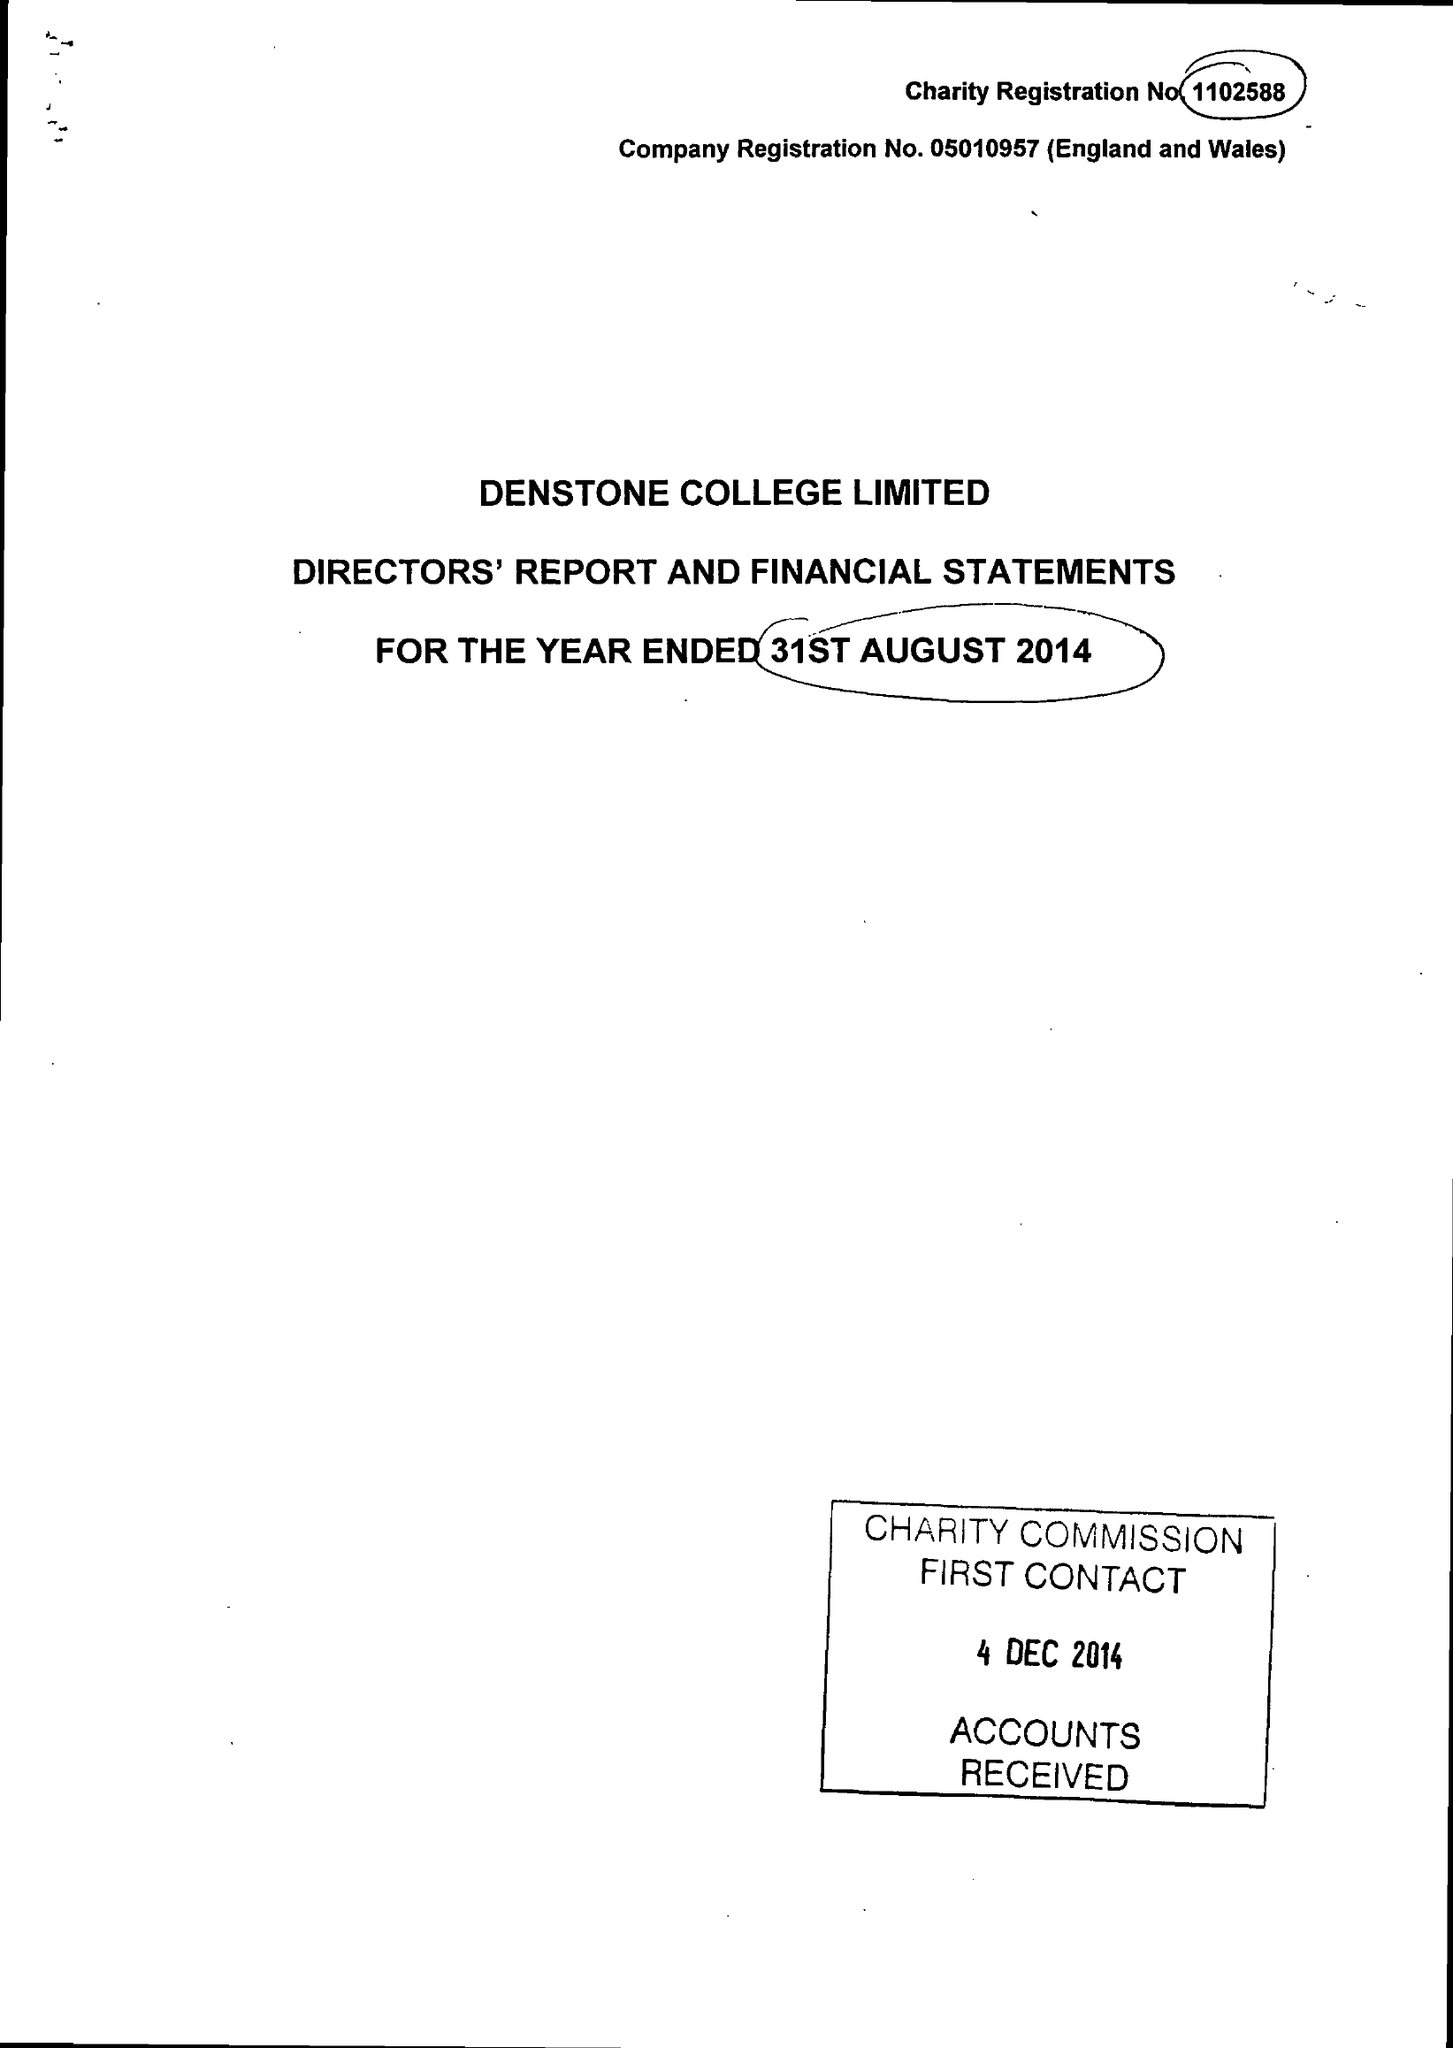What is the value for the spending_annually_in_british_pounds?
Answer the question using a single word or phrase. 8508218.00 